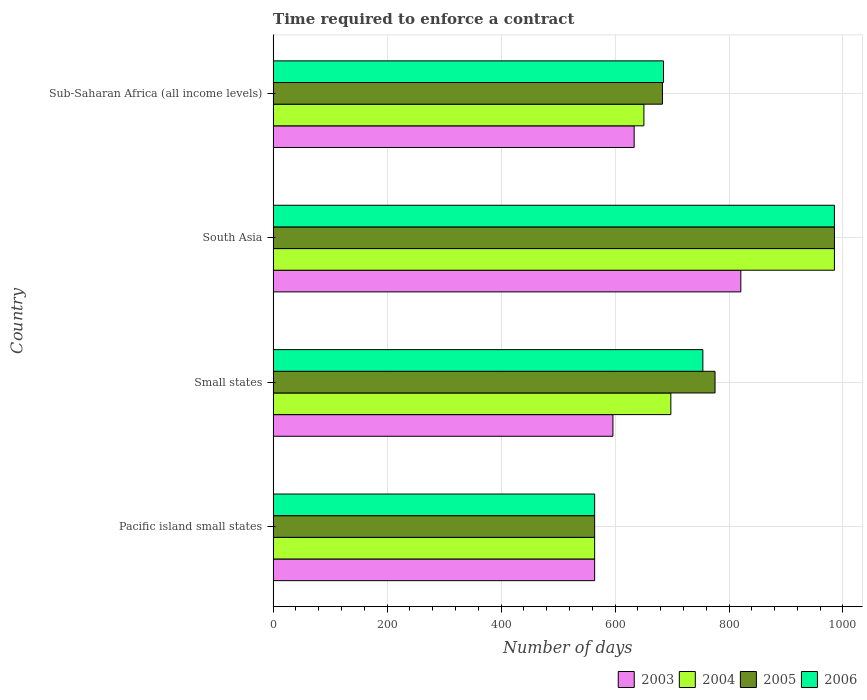How many different coloured bars are there?
Offer a terse response. 4. How many bars are there on the 3rd tick from the bottom?
Offer a very short reply. 4. What is the label of the 4th group of bars from the top?
Offer a terse response. Pacific island small states. What is the number of days required to enforce a contract in 2004 in Pacific island small states?
Offer a very short reply. 564.22. Across all countries, what is the maximum number of days required to enforce a contract in 2006?
Provide a succinct answer. 985. Across all countries, what is the minimum number of days required to enforce a contract in 2006?
Offer a very short reply. 564.22. In which country was the number of days required to enforce a contract in 2006 maximum?
Make the answer very short. South Asia. In which country was the number of days required to enforce a contract in 2003 minimum?
Provide a short and direct response. Pacific island small states. What is the total number of days required to enforce a contract in 2006 in the graph?
Your answer should be compact. 2988.4. What is the difference between the number of days required to enforce a contract in 2003 in Pacific island small states and that in Small states?
Provide a succinct answer. -32.11. What is the difference between the number of days required to enforce a contract in 2005 in South Asia and the number of days required to enforce a contract in 2006 in Pacific island small states?
Ensure brevity in your answer.  420.78. What is the average number of days required to enforce a contract in 2004 per country?
Offer a terse response. 724.46. What is the difference between the number of days required to enforce a contract in 2005 and number of days required to enforce a contract in 2006 in Small states?
Offer a terse response. 21.35. In how many countries, is the number of days required to enforce a contract in 2003 greater than 80 days?
Your answer should be compact. 4. What is the ratio of the number of days required to enforce a contract in 2003 in Small states to that in Sub-Saharan Africa (all income levels)?
Offer a very short reply. 0.94. Is the number of days required to enforce a contract in 2005 in Pacific island small states less than that in South Asia?
Offer a terse response. Yes. Is the difference between the number of days required to enforce a contract in 2005 in Small states and Sub-Saharan Africa (all income levels) greater than the difference between the number of days required to enforce a contract in 2006 in Small states and Sub-Saharan Africa (all income levels)?
Make the answer very short. Yes. What is the difference between the highest and the second highest number of days required to enforce a contract in 2004?
Your response must be concise. 287.05. What is the difference between the highest and the lowest number of days required to enforce a contract in 2004?
Your answer should be very brief. 420.78. In how many countries, is the number of days required to enforce a contract in 2003 greater than the average number of days required to enforce a contract in 2003 taken over all countries?
Provide a short and direct response. 1. Is it the case that in every country, the sum of the number of days required to enforce a contract in 2004 and number of days required to enforce a contract in 2003 is greater than the sum of number of days required to enforce a contract in 2006 and number of days required to enforce a contract in 2005?
Make the answer very short. No. What does the 2nd bar from the top in Pacific island small states represents?
Your response must be concise. 2005. What does the 2nd bar from the bottom in South Asia represents?
Your answer should be very brief. 2004. How many countries are there in the graph?
Ensure brevity in your answer.  4. Are the values on the major ticks of X-axis written in scientific E-notation?
Ensure brevity in your answer.  No. Does the graph contain any zero values?
Make the answer very short. No. Does the graph contain grids?
Your answer should be very brief. Yes. How many legend labels are there?
Provide a short and direct response. 4. How are the legend labels stacked?
Make the answer very short. Horizontal. What is the title of the graph?
Offer a terse response. Time required to enforce a contract. Does "2004" appear as one of the legend labels in the graph?
Make the answer very short. Yes. What is the label or title of the X-axis?
Offer a very short reply. Number of days. What is the label or title of the Y-axis?
Offer a terse response. Country. What is the Number of days in 2003 in Pacific island small states?
Your response must be concise. 564.22. What is the Number of days in 2004 in Pacific island small states?
Offer a terse response. 564.22. What is the Number of days in 2005 in Pacific island small states?
Keep it short and to the point. 564.22. What is the Number of days in 2006 in Pacific island small states?
Ensure brevity in your answer.  564.22. What is the Number of days of 2003 in Small states?
Make the answer very short. 596.33. What is the Number of days in 2004 in Small states?
Make the answer very short. 697.95. What is the Number of days in 2005 in Small states?
Provide a succinct answer. 775.49. What is the Number of days in 2006 in Small states?
Make the answer very short. 754.13. What is the Number of days of 2003 in South Asia?
Your answer should be very brief. 820.75. What is the Number of days in 2004 in South Asia?
Your response must be concise. 985. What is the Number of days in 2005 in South Asia?
Ensure brevity in your answer.  985. What is the Number of days in 2006 in South Asia?
Your answer should be compact. 985. What is the Number of days in 2003 in Sub-Saharan Africa (all income levels)?
Keep it short and to the point. 633.56. What is the Number of days of 2004 in Sub-Saharan Africa (all income levels)?
Your answer should be very brief. 650.67. What is the Number of days in 2005 in Sub-Saharan Africa (all income levels)?
Offer a terse response. 683.18. What is the Number of days of 2006 in Sub-Saharan Africa (all income levels)?
Ensure brevity in your answer.  685.04. Across all countries, what is the maximum Number of days in 2003?
Provide a succinct answer. 820.75. Across all countries, what is the maximum Number of days in 2004?
Provide a short and direct response. 985. Across all countries, what is the maximum Number of days in 2005?
Your answer should be compact. 985. Across all countries, what is the maximum Number of days in 2006?
Give a very brief answer. 985. Across all countries, what is the minimum Number of days of 2003?
Provide a short and direct response. 564.22. Across all countries, what is the minimum Number of days in 2004?
Give a very brief answer. 564.22. Across all countries, what is the minimum Number of days in 2005?
Keep it short and to the point. 564.22. Across all countries, what is the minimum Number of days of 2006?
Your answer should be compact. 564.22. What is the total Number of days of 2003 in the graph?
Offer a terse response. 2614.87. What is the total Number of days in 2004 in the graph?
Make the answer very short. 2897.84. What is the total Number of days in 2005 in the graph?
Keep it short and to the point. 3007.89. What is the total Number of days of 2006 in the graph?
Provide a succinct answer. 2988.4. What is the difference between the Number of days of 2003 in Pacific island small states and that in Small states?
Give a very brief answer. -32.11. What is the difference between the Number of days of 2004 in Pacific island small states and that in Small states?
Your answer should be compact. -133.73. What is the difference between the Number of days of 2005 in Pacific island small states and that in Small states?
Your answer should be very brief. -211.26. What is the difference between the Number of days of 2006 in Pacific island small states and that in Small states?
Offer a very short reply. -189.91. What is the difference between the Number of days of 2003 in Pacific island small states and that in South Asia?
Give a very brief answer. -256.53. What is the difference between the Number of days in 2004 in Pacific island small states and that in South Asia?
Ensure brevity in your answer.  -420.78. What is the difference between the Number of days of 2005 in Pacific island small states and that in South Asia?
Provide a short and direct response. -420.78. What is the difference between the Number of days of 2006 in Pacific island small states and that in South Asia?
Keep it short and to the point. -420.78. What is the difference between the Number of days in 2003 in Pacific island small states and that in Sub-Saharan Africa (all income levels)?
Give a very brief answer. -69.34. What is the difference between the Number of days in 2004 in Pacific island small states and that in Sub-Saharan Africa (all income levels)?
Your answer should be compact. -86.44. What is the difference between the Number of days of 2005 in Pacific island small states and that in Sub-Saharan Africa (all income levels)?
Give a very brief answer. -118.96. What is the difference between the Number of days in 2006 in Pacific island small states and that in Sub-Saharan Africa (all income levels)?
Your response must be concise. -120.82. What is the difference between the Number of days in 2003 in Small states and that in South Asia?
Give a very brief answer. -224.42. What is the difference between the Number of days in 2004 in Small states and that in South Asia?
Offer a terse response. -287.05. What is the difference between the Number of days in 2005 in Small states and that in South Asia?
Offer a terse response. -209.51. What is the difference between the Number of days of 2006 in Small states and that in South Asia?
Offer a terse response. -230.87. What is the difference between the Number of days in 2003 in Small states and that in Sub-Saharan Africa (all income levels)?
Keep it short and to the point. -37.23. What is the difference between the Number of days of 2004 in Small states and that in Sub-Saharan Africa (all income levels)?
Offer a very short reply. 47.28. What is the difference between the Number of days of 2005 in Small states and that in Sub-Saharan Africa (all income levels)?
Your response must be concise. 92.3. What is the difference between the Number of days in 2006 in Small states and that in Sub-Saharan Africa (all income levels)?
Your answer should be very brief. 69.09. What is the difference between the Number of days in 2003 in South Asia and that in Sub-Saharan Africa (all income levels)?
Provide a succinct answer. 187.19. What is the difference between the Number of days in 2004 in South Asia and that in Sub-Saharan Africa (all income levels)?
Your answer should be very brief. 334.33. What is the difference between the Number of days in 2005 in South Asia and that in Sub-Saharan Africa (all income levels)?
Keep it short and to the point. 301.82. What is the difference between the Number of days of 2006 in South Asia and that in Sub-Saharan Africa (all income levels)?
Keep it short and to the point. 299.96. What is the difference between the Number of days in 2003 in Pacific island small states and the Number of days in 2004 in Small states?
Keep it short and to the point. -133.73. What is the difference between the Number of days of 2003 in Pacific island small states and the Number of days of 2005 in Small states?
Keep it short and to the point. -211.26. What is the difference between the Number of days of 2003 in Pacific island small states and the Number of days of 2006 in Small states?
Your answer should be very brief. -189.91. What is the difference between the Number of days in 2004 in Pacific island small states and the Number of days in 2005 in Small states?
Provide a short and direct response. -211.26. What is the difference between the Number of days of 2004 in Pacific island small states and the Number of days of 2006 in Small states?
Your answer should be compact. -189.91. What is the difference between the Number of days of 2005 in Pacific island small states and the Number of days of 2006 in Small states?
Provide a succinct answer. -189.91. What is the difference between the Number of days of 2003 in Pacific island small states and the Number of days of 2004 in South Asia?
Your response must be concise. -420.78. What is the difference between the Number of days of 2003 in Pacific island small states and the Number of days of 2005 in South Asia?
Keep it short and to the point. -420.78. What is the difference between the Number of days of 2003 in Pacific island small states and the Number of days of 2006 in South Asia?
Your response must be concise. -420.78. What is the difference between the Number of days of 2004 in Pacific island small states and the Number of days of 2005 in South Asia?
Give a very brief answer. -420.78. What is the difference between the Number of days of 2004 in Pacific island small states and the Number of days of 2006 in South Asia?
Offer a terse response. -420.78. What is the difference between the Number of days of 2005 in Pacific island small states and the Number of days of 2006 in South Asia?
Offer a terse response. -420.78. What is the difference between the Number of days in 2003 in Pacific island small states and the Number of days in 2004 in Sub-Saharan Africa (all income levels)?
Your response must be concise. -86.44. What is the difference between the Number of days of 2003 in Pacific island small states and the Number of days of 2005 in Sub-Saharan Africa (all income levels)?
Your answer should be very brief. -118.96. What is the difference between the Number of days in 2003 in Pacific island small states and the Number of days in 2006 in Sub-Saharan Africa (all income levels)?
Ensure brevity in your answer.  -120.82. What is the difference between the Number of days in 2004 in Pacific island small states and the Number of days in 2005 in Sub-Saharan Africa (all income levels)?
Offer a very short reply. -118.96. What is the difference between the Number of days in 2004 in Pacific island small states and the Number of days in 2006 in Sub-Saharan Africa (all income levels)?
Provide a succinct answer. -120.82. What is the difference between the Number of days in 2005 in Pacific island small states and the Number of days in 2006 in Sub-Saharan Africa (all income levels)?
Offer a terse response. -120.82. What is the difference between the Number of days of 2003 in Small states and the Number of days of 2004 in South Asia?
Ensure brevity in your answer.  -388.67. What is the difference between the Number of days of 2003 in Small states and the Number of days of 2005 in South Asia?
Provide a succinct answer. -388.67. What is the difference between the Number of days of 2003 in Small states and the Number of days of 2006 in South Asia?
Your answer should be compact. -388.67. What is the difference between the Number of days of 2004 in Small states and the Number of days of 2005 in South Asia?
Keep it short and to the point. -287.05. What is the difference between the Number of days in 2004 in Small states and the Number of days in 2006 in South Asia?
Your response must be concise. -287.05. What is the difference between the Number of days of 2005 in Small states and the Number of days of 2006 in South Asia?
Provide a short and direct response. -209.51. What is the difference between the Number of days in 2003 in Small states and the Number of days in 2004 in Sub-Saharan Africa (all income levels)?
Offer a terse response. -54.33. What is the difference between the Number of days in 2003 in Small states and the Number of days in 2005 in Sub-Saharan Africa (all income levels)?
Make the answer very short. -86.85. What is the difference between the Number of days in 2003 in Small states and the Number of days in 2006 in Sub-Saharan Africa (all income levels)?
Your answer should be compact. -88.71. What is the difference between the Number of days of 2004 in Small states and the Number of days of 2005 in Sub-Saharan Africa (all income levels)?
Offer a terse response. 14.77. What is the difference between the Number of days in 2004 in Small states and the Number of days in 2006 in Sub-Saharan Africa (all income levels)?
Offer a very short reply. 12.9. What is the difference between the Number of days of 2005 in Small states and the Number of days of 2006 in Sub-Saharan Africa (all income levels)?
Ensure brevity in your answer.  90.44. What is the difference between the Number of days in 2003 in South Asia and the Number of days in 2004 in Sub-Saharan Africa (all income levels)?
Provide a short and direct response. 170.08. What is the difference between the Number of days of 2003 in South Asia and the Number of days of 2005 in Sub-Saharan Africa (all income levels)?
Offer a very short reply. 137.57. What is the difference between the Number of days in 2003 in South Asia and the Number of days in 2006 in Sub-Saharan Africa (all income levels)?
Your response must be concise. 135.71. What is the difference between the Number of days of 2004 in South Asia and the Number of days of 2005 in Sub-Saharan Africa (all income levels)?
Make the answer very short. 301.82. What is the difference between the Number of days of 2004 in South Asia and the Number of days of 2006 in Sub-Saharan Africa (all income levels)?
Your answer should be compact. 299.96. What is the difference between the Number of days in 2005 in South Asia and the Number of days in 2006 in Sub-Saharan Africa (all income levels)?
Keep it short and to the point. 299.96. What is the average Number of days in 2003 per country?
Keep it short and to the point. 653.72. What is the average Number of days in 2004 per country?
Offer a very short reply. 724.46. What is the average Number of days in 2005 per country?
Ensure brevity in your answer.  751.97. What is the average Number of days in 2006 per country?
Provide a short and direct response. 747.1. What is the difference between the Number of days in 2003 and Number of days in 2006 in Pacific island small states?
Offer a terse response. 0. What is the difference between the Number of days of 2004 and Number of days of 2006 in Pacific island small states?
Your response must be concise. 0. What is the difference between the Number of days of 2005 and Number of days of 2006 in Pacific island small states?
Give a very brief answer. 0. What is the difference between the Number of days in 2003 and Number of days in 2004 in Small states?
Keep it short and to the point. -101.61. What is the difference between the Number of days in 2003 and Number of days in 2005 in Small states?
Give a very brief answer. -179.15. What is the difference between the Number of days of 2003 and Number of days of 2006 in Small states?
Your response must be concise. -157.8. What is the difference between the Number of days of 2004 and Number of days of 2005 in Small states?
Give a very brief answer. -77.54. What is the difference between the Number of days in 2004 and Number of days in 2006 in Small states?
Your answer should be very brief. -56.18. What is the difference between the Number of days of 2005 and Number of days of 2006 in Small states?
Your answer should be compact. 21.35. What is the difference between the Number of days of 2003 and Number of days of 2004 in South Asia?
Offer a terse response. -164.25. What is the difference between the Number of days of 2003 and Number of days of 2005 in South Asia?
Provide a short and direct response. -164.25. What is the difference between the Number of days of 2003 and Number of days of 2006 in South Asia?
Your answer should be compact. -164.25. What is the difference between the Number of days in 2004 and Number of days in 2005 in South Asia?
Keep it short and to the point. 0. What is the difference between the Number of days of 2004 and Number of days of 2006 in South Asia?
Provide a short and direct response. 0. What is the difference between the Number of days of 2003 and Number of days of 2004 in Sub-Saharan Africa (all income levels)?
Ensure brevity in your answer.  -17.1. What is the difference between the Number of days in 2003 and Number of days in 2005 in Sub-Saharan Africa (all income levels)?
Keep it short and to the point. -49.62. What is the difference between the Number of days in 2003 and Number of days in 2006 in Sub-Saharan Africa (all income levels)?
Keep it short and to the point. -51.48. What is the difference between the Number of days in 2004 and Number of days in 2005 in Sub-Saharan Africa (all income levels)?
Keep it short and to the point. -32.52. What is the difference between the Number of days in 2004 and Number of days in 2006 in Sub-Saharan Africa (all income levels)?
Make the answer very short. -34.38. What is the difference between the Number of days of 2005 and Number of days of 2006 in Sub-Saharan Africa (all income levels)?
Your response must be concise. -1.86. What is the ratio of the Number of days of 2003 in Pacific island small states to that in Small states?
Provide a short and direct response. 0.95. What is the ratio of the Number of days of 2004 in Pacific island small states to that in Small states?
Offer a terse response. 0.81. What is the ratio of the Number of days of 2005 in Pacific island small states to that in Small states?
Ensure brevity in your answer.  0.73. What is the ratio of the Number of days in 2006 in Pacific island small states to that in Small states?
Provide a short and direct response. 0.75. What is the ratio of the Number of days of 2003 in Pacific island small states to that in South Asia?
Give a very brief answer. 0.69. What is the ratio of the Number of days of 2004 in Pacific island small states to that in South Asia?
Make the answer very short. 0.57. What is the ratio of the Number of days in 2005 in Pacific island small states to that in South Asia?
Your answer should be very brief. 0.57. What is the ratio of the Number of days in 2006 in Pacific island small states to that in South Asia?
Your response must be concise. 0.57. What is the ratio of the Number of days of 2003 in Pacific island small states to that in Sub-Saharan Africa (all income levels)?
Provide a succinct answer. 0.89. What is the ratio of the Number of days in 2004 in Pacific island small states to that in Sub-Saharan Africa (all income levels)?
Make the answer very short. 0.87. What is the ratio of the Number of days in 2005 in Pacific island small states to that in Sub-Saharan Africa (all income levels)?
Your response must be concise. 0.83. What is the ratio of the Number of days of 2006 in Pacific island small states to that in Sub-Saharan Africa (all income levels)?
Offer a very short reply. 0.82. What is the ratio of the Number of days in 2003 in Small states to that in South Asia?
Ensure brevity in your answer.  0.73. What is the ratio of the Number of days of 2004 in Small states to that in South Asia?
Give a very brief answer. 0.71. What is the ratio of the Number of days of 2005 in Small states to that in South Asia?
Your answer should be very brief. 0.79. What is the ratio of the Number of days of 2006 in Small states to that in South Asia?
Your answer should be very brief. 0.77. What is the ratio of the Number of days of 2004 in Small states to that in Sub-Saharan Africa (all income levels)?
Ensure brevity in your answer.  1.07. What is the ratio of the Number of days in 2005 in Small states to that in Sub-Saharan Africa (all income levels)?
Provide a short and direct response. 1.14. What is the ratio of the Number of days of 2006 in Small states to that in Sub-Saharan Africa (all income levels)?
Keep it short and to the point. 1.1. What is the ratio of the Number of days in 2003 in South Asia to that in Sub-Saharan Africa (all income levels)?
Keep it short and to the point. 1.3. What is the ratio of the Number of days in 2004 in South Asia to that in Sub-Saharan Africa (all income levels)?
Keep it short and to the point. 1.51. What is the ratio of the Number of days in 2005 in South Asia to that in Sub-Saharan Africa (all income levels)?
Provide a succinct answer. 1.44. What is the ratio of the Number of days of 2006 in South Asia to that in Sub-Saharan Africa (all income levels)?
Ensure brevity in your answer.  1.44. What is the difference between the highest and the second highest Number of days of 2003?
Provide a succinct answer. 187.19. What is the difference between the highest and the second highest Number of days in 2004?
Your answer should be compact. 287.05. What is the difference between the highest and the second highest Number of days in 2005?
Offer a terse response. 209.51. What is the difference between the highest and the second highest Number of days of 2006?
Offer a terse response. 230.87. What is the difference between the highest and the lowest Number of days of 2003?
Keep it short and to the point. 256.53. What is the difference between the highest and the lowest Number of days in 2004?
Your answer should be compact. 420.78. What is the difference between the highest and the lowest Number of days in 2005?
Offer a very short reply. 420.78. What is the difference between the highest and the lowest Number of days of 2006?
Offer a very short reply. 420.78. 